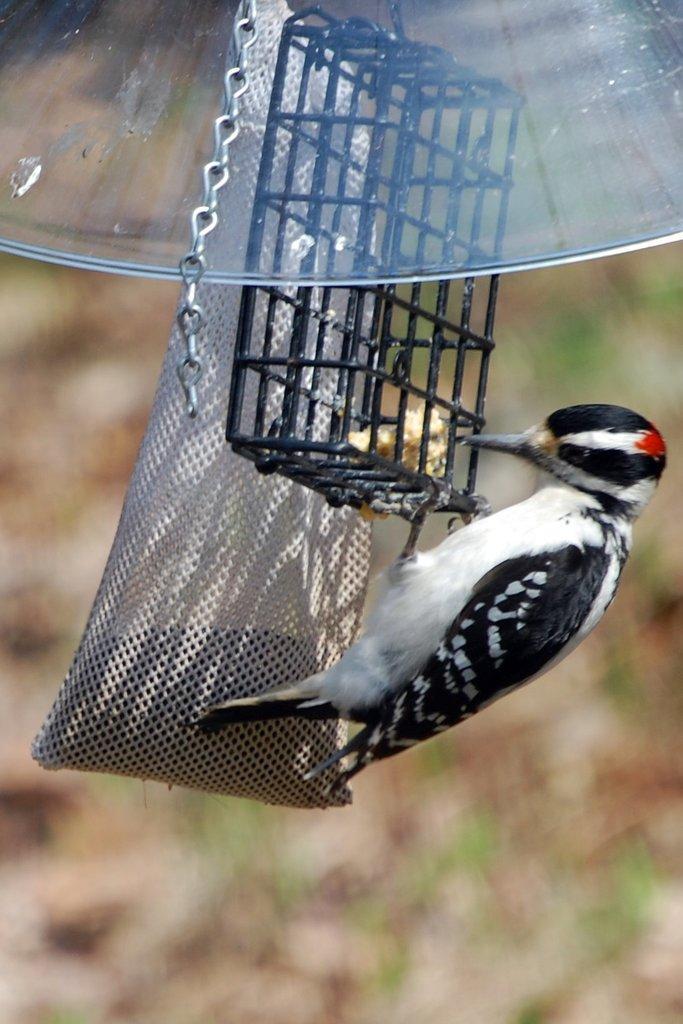How would you summarize this image in a sentence or two? In this image we can see a bird beside a cage. We can also see a bag and a chain to it. 